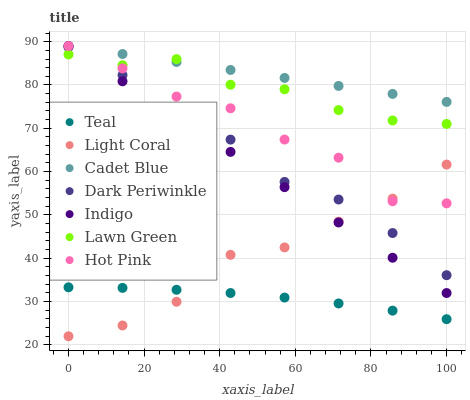Does Teal have the minimum area under the curve?
Answer yes or no. Yes. Does Cadet Blue have the maximum area under the curve?
Answer yes or no. Yes. Does Indigo have the minimum area under the curve?
Answer yes or no. No. Does Indigo have the maximum area under the curve?
Answer yes or no. No. Is Indigo the smoothest?
Answer yes or no. Yes. Is Dark Periwinkle the roughest?
Answer yes or no. Yes. Is Cadet Blue the smoothest?
Answer yes or no. No. Is Cadet Blue the roughest?
Answer yes or no. No. Does Light Coral have the lowest value?
Answer yes or no. Yes. Does Indigo have the lowest value?
Answer yes or no. No. Does Hot Pink have the highest value?
Answer yes or no. Yes. Does Light Coral have the highest value?
Answer yes or no. No. Is Dark Periwinkle less than Hot Pink?
Answer yes or no. Yes. Is Lawn Green greater than Light Coral?
Answer yes or no. Yes. Does Indigo intersect Lawn Green?
Answer yes or no. Yes. Is Indigo less than Lawn Green?
Answer yes or no. No. Is Indigo greater than Lawn Green?
Answer yes or no. No. Does Dark Periwinkle intersect Hot Pink?
Answer yes or no. No. 